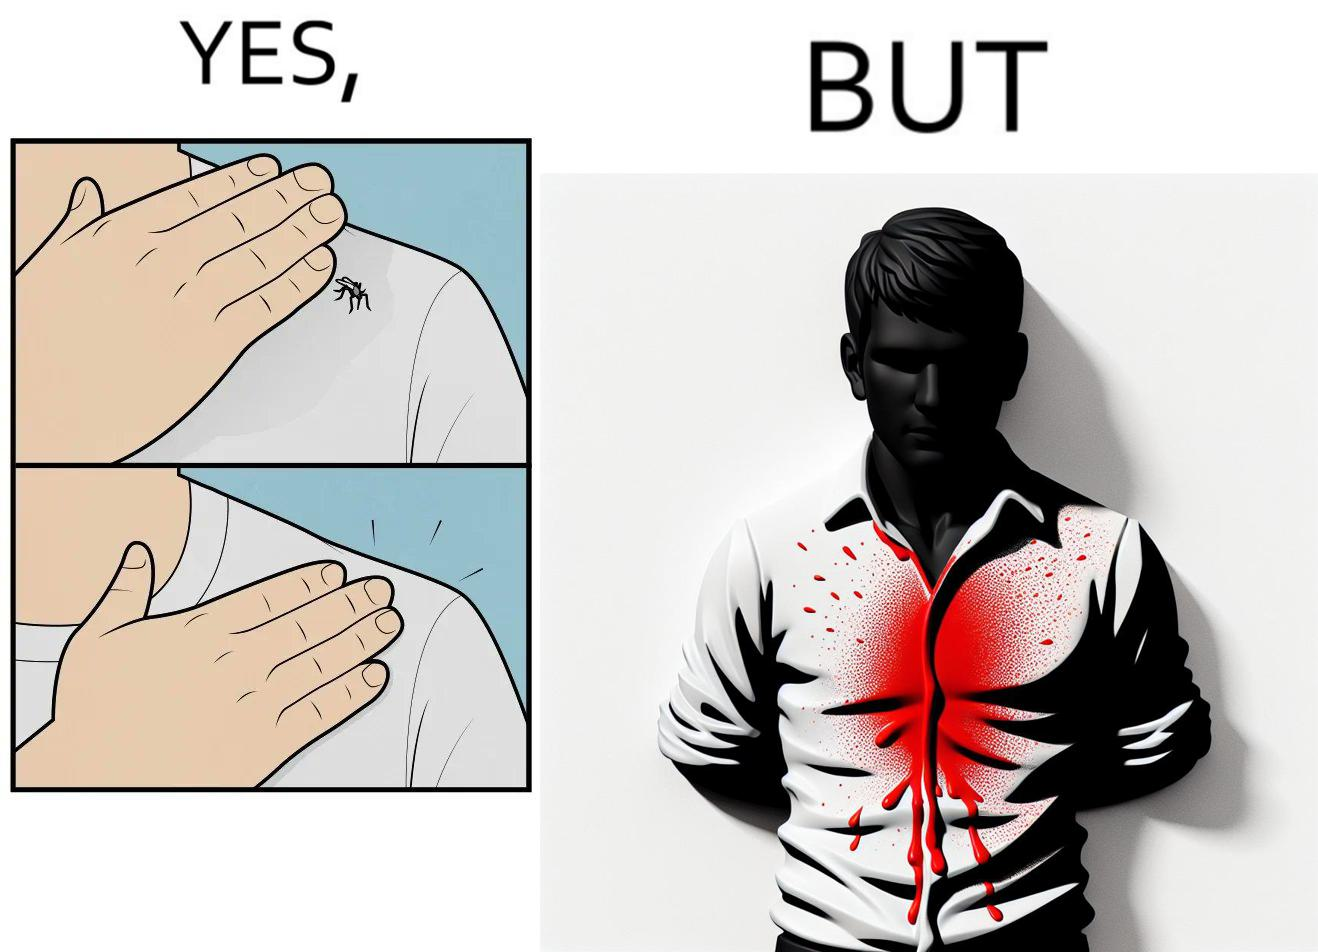Describe the content of this image. The images are funny since a man trying to reduce his irritation by killing a mosquito bothering  him only causes himself more irritation by soiling his t-shirt with the mosquito blood 